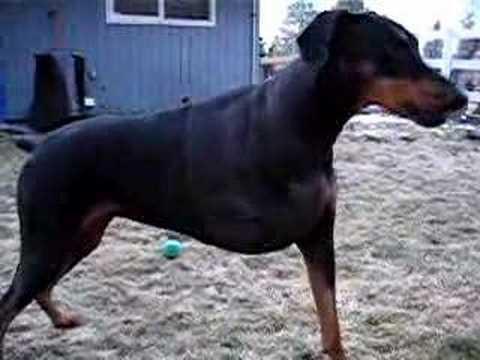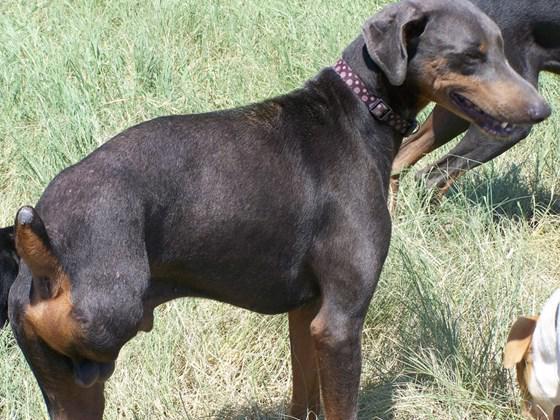The first image is the image on the left, the second image is the image on the right. Assess this claim about the two images: "Each image includes a black-and-tan dog that is standing upright and is missing one limb.". Correct or not? Answer yes or no. Yes. The first image is the image on the left, the second image is the image on the right. Considering the images on both sides, is "At least one of the dogs appears to be missing a back leg." valid? Answer yes or no. Yes. 